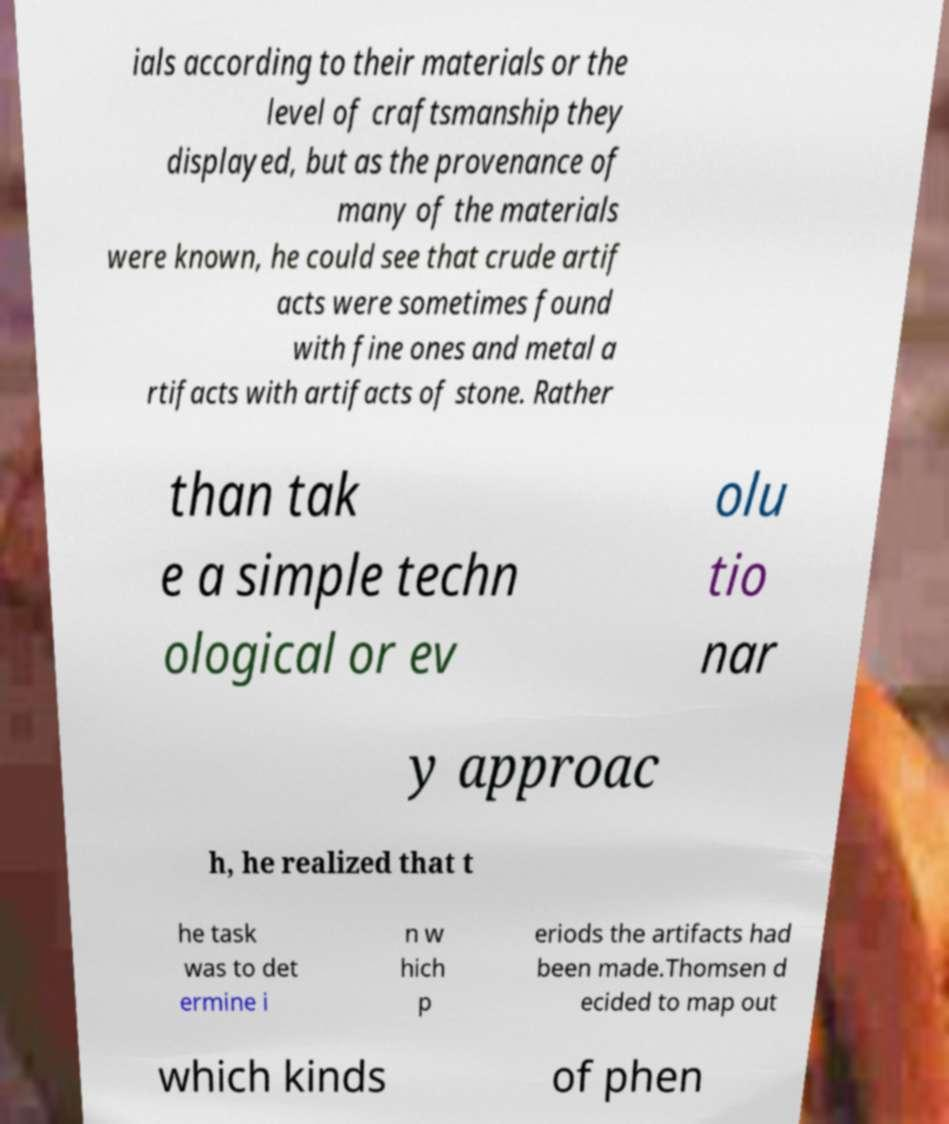Please identify and transcribe the text found in this image. ials according to their materials or the level of craftsmanship they displayed, but as the provenance of many of the materials were known, he could see that crude artif acts were sometimes found with fine ones and metal a rtifacts with artifacts of stone. Rather than tak e a simple techn ological or ev olu tio nar y approac h, he realized that t he task was to det ermine i n w hich p eriods the artifacts had been made.Thomsen d ecided to map out which kinds of phen 